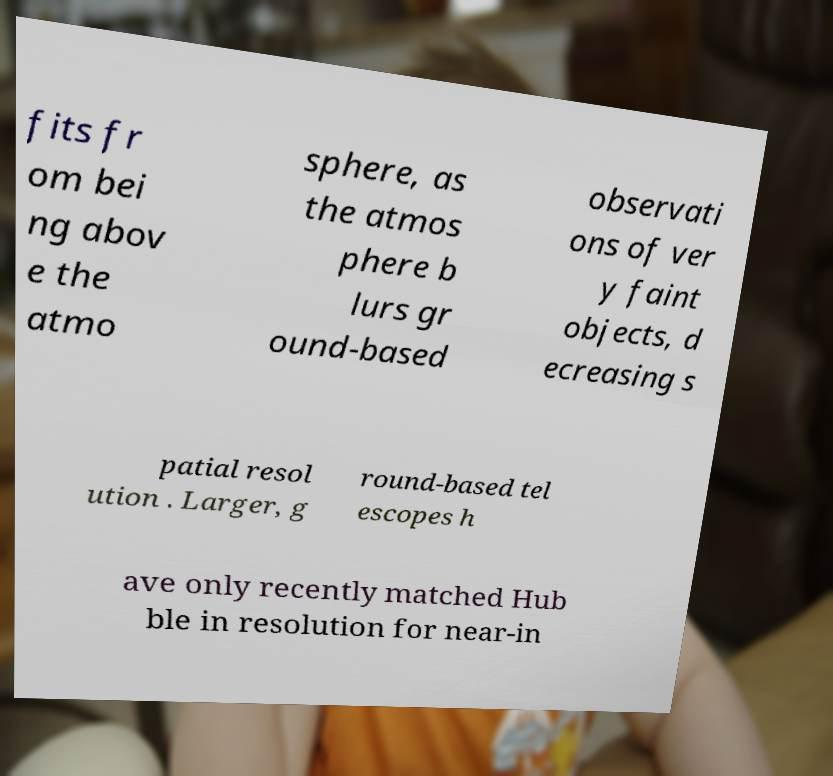Can you read and provide the text displayed in the image?This photo seems to have some interesting text. Can you extract and type it out for me? fits fr om bei ng abov e the atmo sphere, as the atmos phere b lurs gr ound-based observati ons of ver y faint objects, d ecreasing s patial resol ution . Larger, g round-based tel escopes h ave only recently matched Hub ble in resolution for near-in 